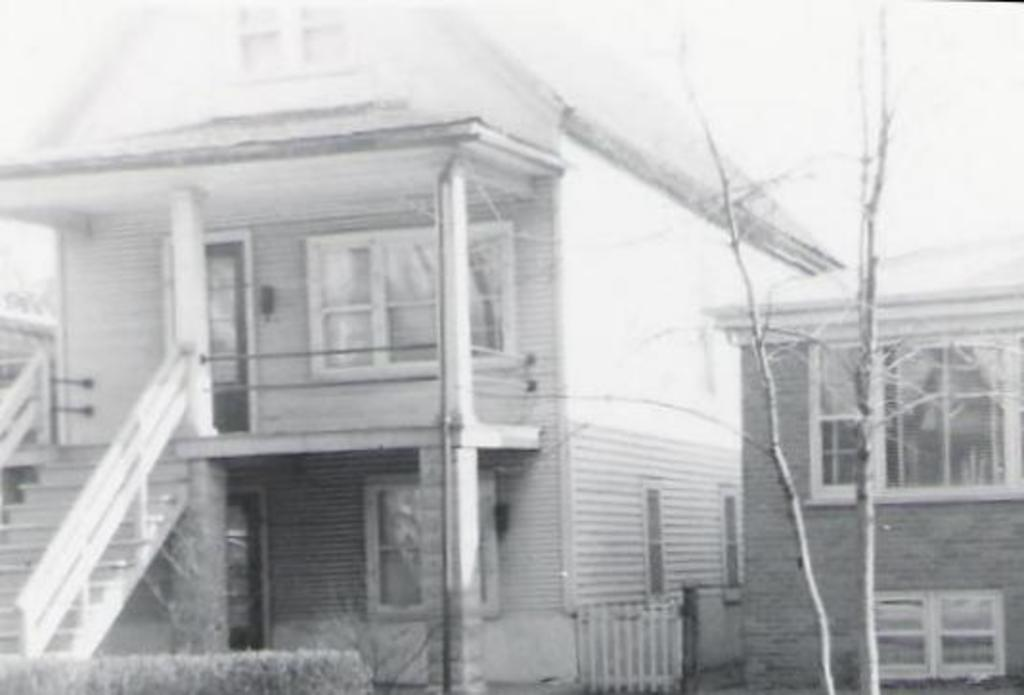What type of structures are visible in the image? There are houses in the image. What is located in the front of the image? There is a tree in the front of the image. What features can be seen on the houses? The image contains a door and windows. What is the color scheme of the image? The image is black and white. What architectural element is present on the left side of the image? There are stairs on the left side of the image. Can you hear the bells ringing in the image? There are no bells present in the image, so it is not possible to hear them ringing. 